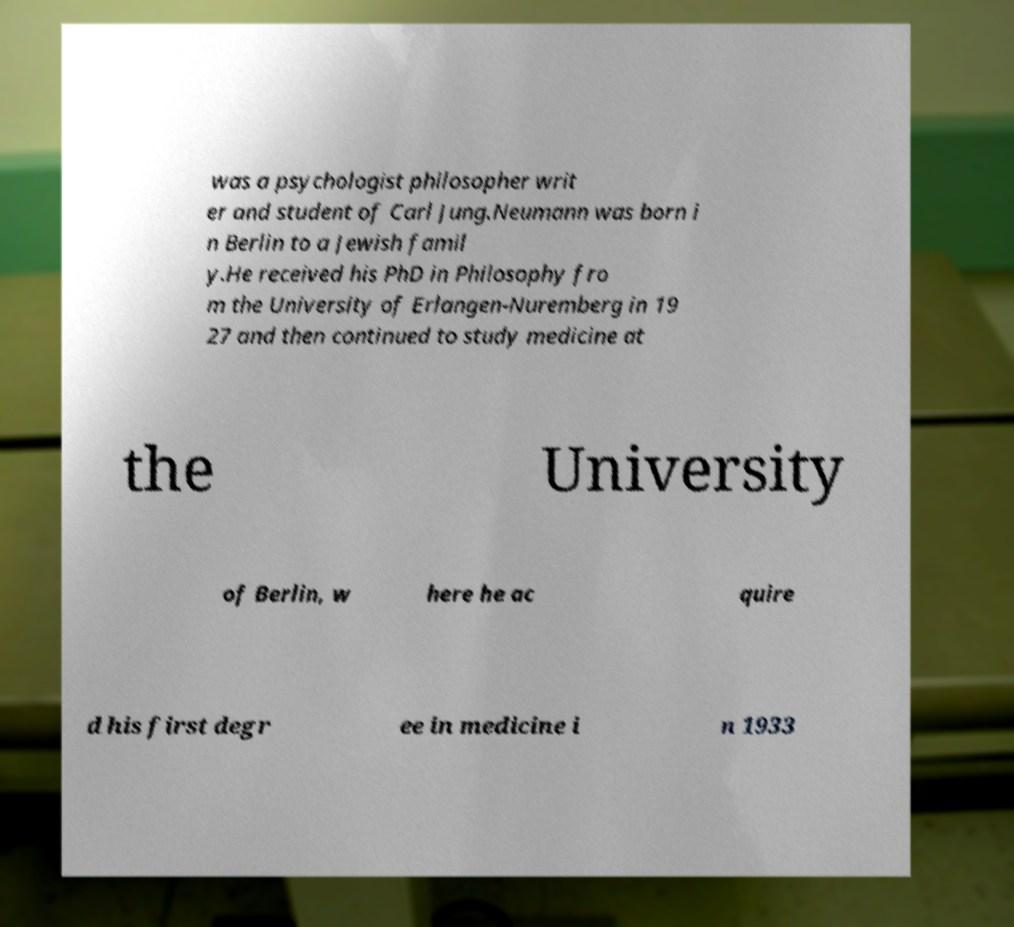Can you accurately transcribe the text from the provided image for me? was a psychologist philosopher writ er and student of Carl Jung.Neumann was born i n Berlin to a Jewish famil y.He received his PhD in Philosophy fro m the University of Erlangen-Nuremberg in 19 27 and then continued to study medicine at the University of Berlin, w here he ac quire d his first degr ee in medicine i n 1933 